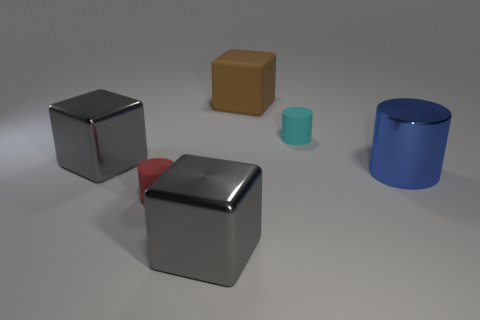There is a cyan object that is the same shape as the big blue object; what material is it?
Provide a succinct answer. Rubber. What number of red cylinders have the same size as the cyan cylinder?
Your response must be concise. 1. What is the shape of the big blue shiny object?
Provide a short and direct response. Cylinder. There is a matte object that is both to the left of the small cyan cylinder and to the right of the small red thing; how big is it?
Offer a terse response. Large. What is the material of the big gray thing behind the small red rubber thing?
Make the answer very short. Metal. There is a big rubber cube; does it have the same color as the tiny thing that is in front of the cyan thing?
Ensure brevity in your answer.  No. How many objects are cylinders on the left side of the large blue metal cylinder or gray shiny cubes that are in front of the big cylinder?
Provide a succinct answer. 3. What is the color of the matte object that is both on the left side of the cyan thing and behind the red object?
Your answer should be compact. Brown. Are there more gray shiny cubes than metallic cylinders?
Provide a short and direct response. Yes. Is the shape of the big shiny object in front of the tiny red rubber cylinder the same as  the cyan thing?
Provide a succinct answer. No. 